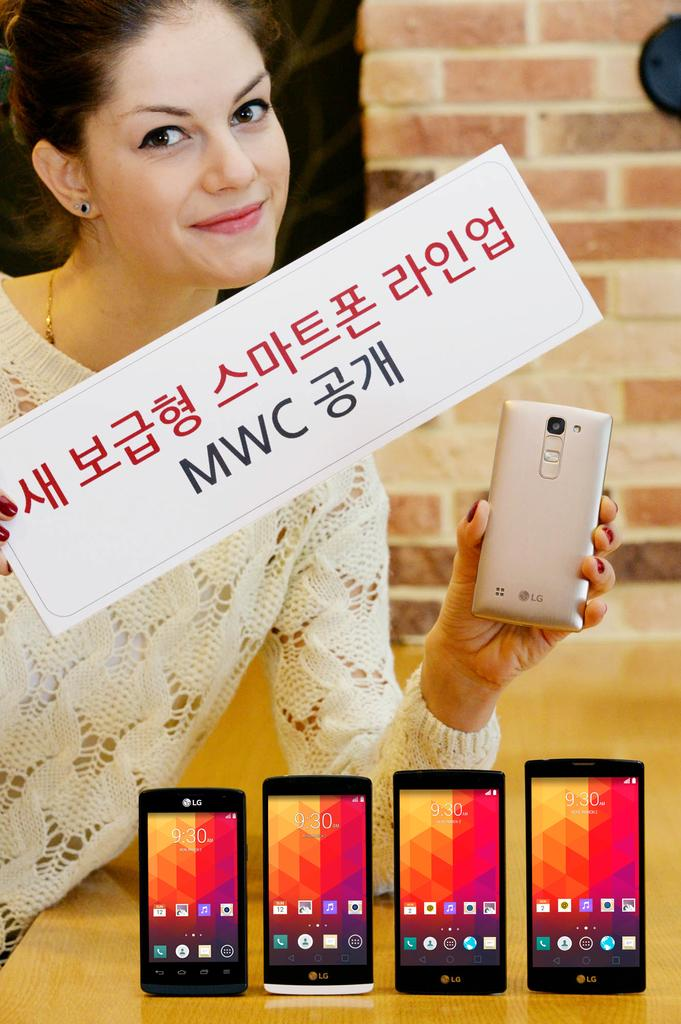Who is present in the image? There is a woman in the image. What is the woman holding in her hand? The woman is holding a card and a mobile. How many mobiles are on the table in the image? There are four mobiles on the table. What can be seen in the background of the image? There is a wall in the background of the image. What type of operation is the woman performing on the tub in the image? There is no tub or operation present in the image; it features a woman holding a card and a mobile, with four mobiles on the table, and a wall in the background. 